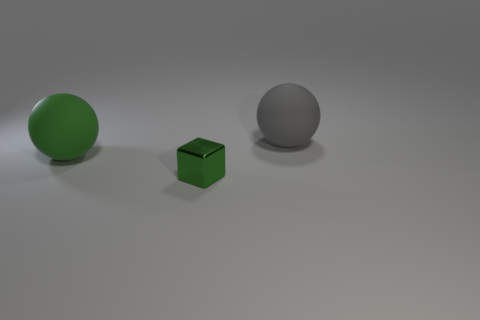What is the color of the other rubber thing that is the same shape as the large green object?
Make the answer very short. Gray. There is a object that is both behind the small green shiny block and right of the big green matte thing; what size is it?
Offer a very short reply. Large. Does the big matte thing that is in front of the large gray sphere have the same shape as the big gray thing that is on the right side of the cube?
Ensure brevity in your answer.  Yes. The big thing that is the same color as the small metal thing is what shape?
Offer a terse response. Sphere. How many gray spheres have the same material as the gray object?
Give a very brief answer. 0. What shape is the thing that is to the left of the big gray rubber sphere and to the right of the big green rubber object?
Your answer should be compact. Cube. Do the large ball that is behind the green ball and the big green ball have the same material?
Offer a very short reply. Yes. Is there anything else that has the same material as the small green cube?
Provide a succinct answer. No. What is the color of the other rubber thing that is the same size as the gray object?
Provide a succinct answer. Green. Are there any blocks that have the same color as the small object?
Your answer should be compact. No. 